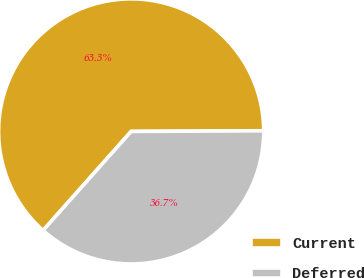Convert chart. <chart><loc_0><loc_0><loc_500><loc_500><pie_chart><fcel>Current<fcel>Deferred<nl><fcel>63.35%<fcel>36.65%<nl></chart> 